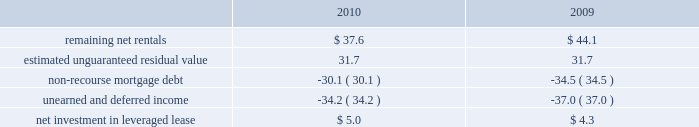Kimco realty corporation and subsidiaries notes to consolidated financial statements , continued investment in retail store leases 2014 the company has interests in various retail store leases relating to the anchor store premises in neighborhood and community shopping centers .
These premises have been sublet to retailers who lease the stores pursuant to net lease agreements .
Income from the investment in these retail store leases during the years ended december 31 , 2010 , 2009 and 2008 , was approximately $ 1.6 million , $ 0.8 million and $ 2.7 million , respectively .
These amounts represent sublease revenues during the years ended december 31 , 2010 , 2009 and 2008 , of approximately $ 5.9 million , $ 5.2 million and $ 7.1 million , respectively , less related expenses of $ 4.3 million , $ 4.4 million and $ 4.4 million , respectively .
The company 2019s future minimum revenues under the terms of all non-cancelable tenant subleases and future minimum obligations through the remaining terms of its retail store leases , assuming no new or renegotiated leases are executed for such premises , for future years are as follows ( in millions ) : 2011 , $ 5.2 and $ 3.4 ; 2012 , $ 4.1 and $ 2.6 ; 2013 , $ 3.8 and $ 2.3 ; 2014 , $ 2.9 and $ 1.7 ; 2015 , $ 2.1 and $ 1.3 , and thereafter , $ 2.8 and $ 1.6 , respectively .
Leveraged lease 2014 during june 2002 , the company acquired a 90% ( 90 % ) equity participation interest in an existing leveraged lease of 30 properties .
The properties are leased under a long-term bond-type net lease whose primary term expires in 2016 , with the lessee having certain renewal option rights .
The company 2019s cash equity investment was approximately $ 4.0 million .
This equity investment is reported as a net investment in leveraged lease in accordance with the fasb 2019s lease guidance .
As of december 31 , 2010 , 18 of these properties were sold , whereby the proceeds from the sales were used to pay down the mortgage debt by approximately $ 31.2 million and the remaining 12 properties were encumbered by third-party non-recourse debt of approximately $ 33.4 million that is scheduled to fully amortize during the primary term of the lease from a portion of the periodic net rents receivable under the net lease .
As an equity participant in the leveraged lease , the company has no recourse obligation for principal or interest payments on the debt , which is collateralized by a first mortgage lien on the properties and collateral assignment of the lease .
Accordingly , this obligation has been offset against the related net rental receivable under the lease .
At december 31 , 2010 and 2009 , the company 2019s net investment in the leveraged lease consisted of the following ( in millions ) : .
10 .
Variable interest entities : consolidated operating properties 2014 included within the company 2019s consolidated operating properties at december 31 , 2010 are four consolidated entities that are vies and for which the company is the primary beneficiary .
All of these entities have been established to own and operate real estate property .
The company 2019s involvement with these entities is through its majority ownership of the properties .
These entities were deemed vies primarily based on the fact that the voting rights of the equity investors are not proportional to their obligation to absorb expected losses or receive the expected residual returns of the entity and substantially all of the entity 2019s activities are conducted on behalf of the investor which has disproportionately fewer voting rights .
The company determined that it was the primary beneficiary of these vies as a result of its controlling financial interest .
During 2010 , the company sold two consolidated vie 2019s which the company was the primary beneficiary. .
What is the growth rate in revenues generated through subleasing in 2010? 
Computations: ((5.9 - 5.2) / 5.2)
Answer: 0.13462. 